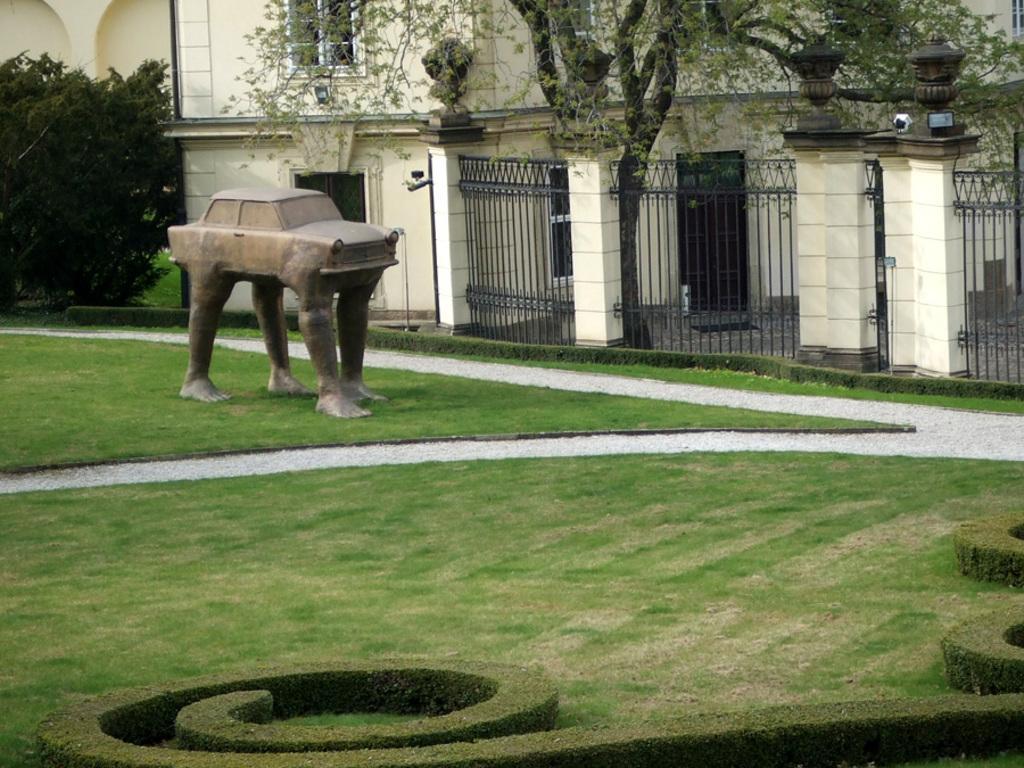In one or two sentences, can you explain what this image depicts? In the background we can see a building, windows and lights. We can see the fence in black color. In this picture we can see the statue near to a building. At the bottom portion of the picture we can see the green grass. 